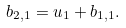<formula> <loc_0><loc_0><loc_500><loc_500>b _ { 2 , 1 } = u _ { 1 } + b _ { 1 , 1 } .</formula> 